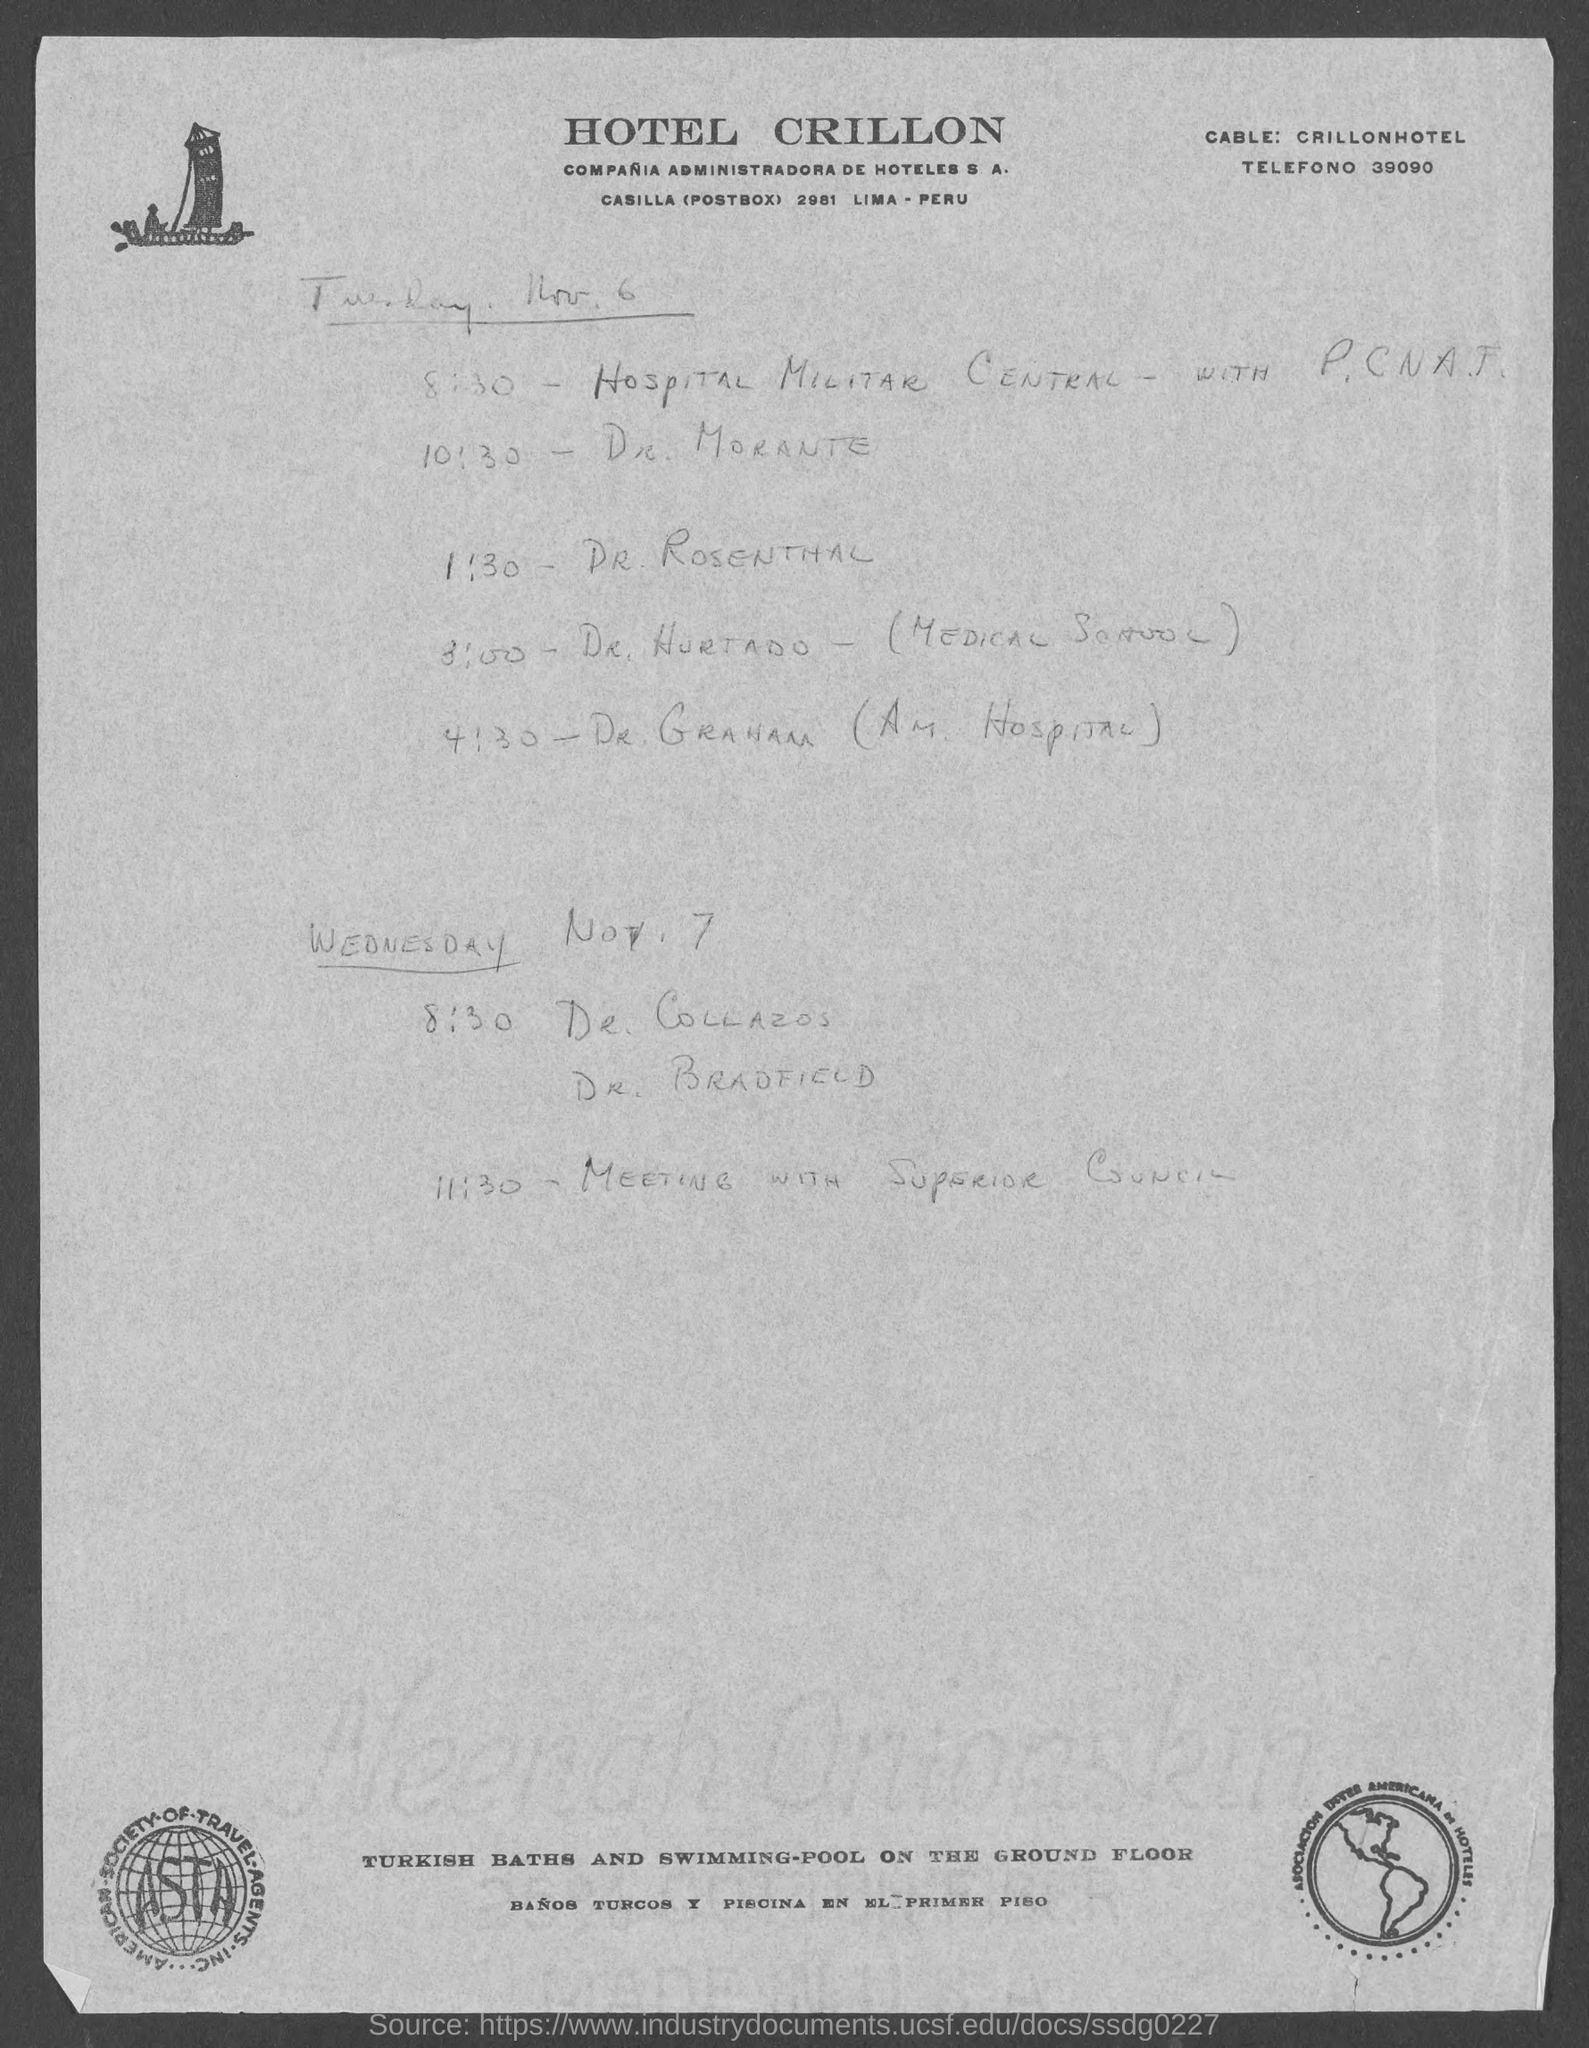What is the name of the"HOTEL" given at the top of the page?
Provide a succinct answer. HOTEL CRILLON. What is the POSTBOX number of HOTEL CRILLON?
Your answer should be compact. 2981. Mention the TELEFONO number given at left top corner of the page?
Provide a short and direct response. 39090. What  is written inside the logo given at left bottom corner of the page?
Keep it short and to the point. ASTA. What is the name of POSTBOX mentioned in HOTEL CRILLON address?
Your answer should be compact. CASILLA. Provide "CABLE:" data given at left top corner of the page?
Ensure brevity in your answer.  CRILLONHOTEL. 